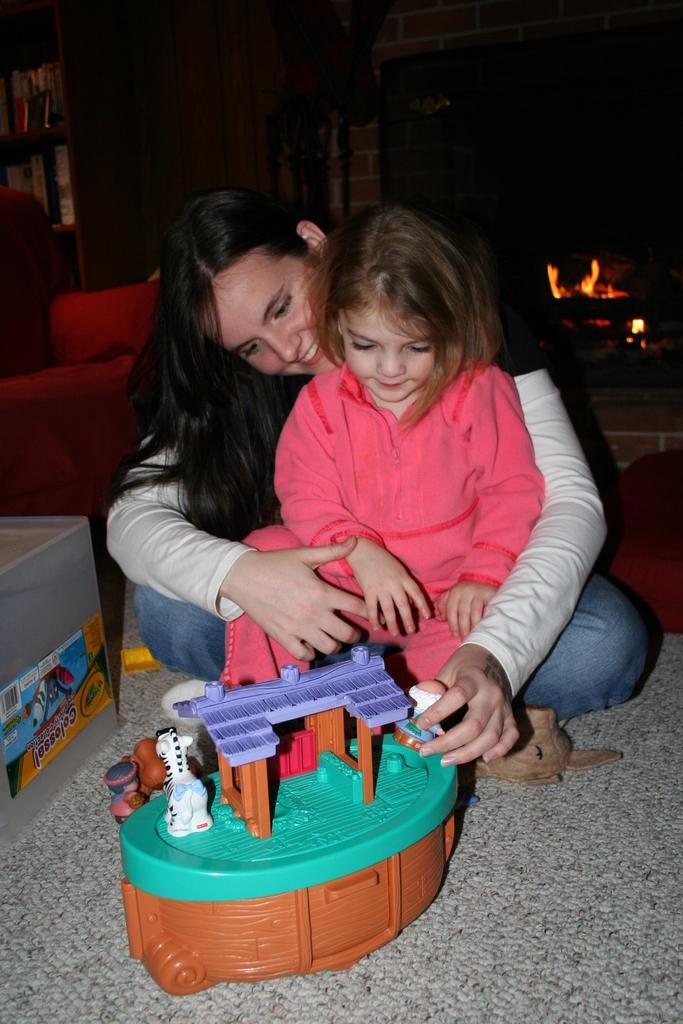Who is present in the image? There is a mother and a small girl in the image. What are they doing in the image? The mother and small girl are sitting on the ground and playing with toys. What can be seen in the background of the image? There is a fireplace in the background of the image, and the background is dark. What type of roof can be seen in the image? There is no roof visible in the image; it is focused on the mother, small girl, and the background. How many trees are present in the image? There are no trees visible in the image. 